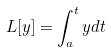Convert formula to latex. <formula><loc_0><loc_0><loc_500><loc_500>L [ y ] = \int _ { a } ^ { t } y d t</formula> 